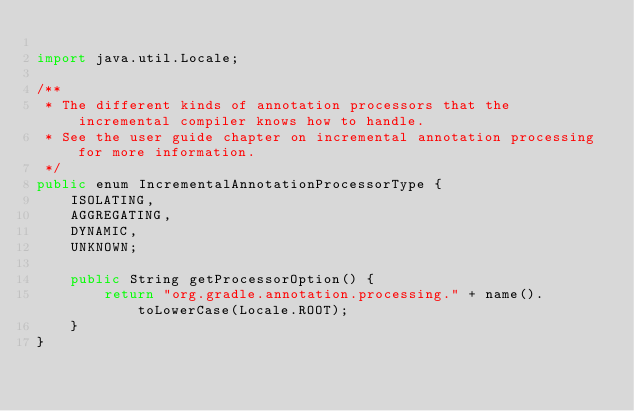Convert code to text. <code><loc_0><loc_0><loc_500><loc_500><_Java_>
import java.util.Locale;

/**
 * The different kinds of annotation processors that the incremental compiler knows how to handle.
 * See the user guide chapter on incremental annotation processing for more information.
 */
public enum IncrementalAnnotationProcessorType {
    ISOLATING,
    AGGREGATING,
    DYNAMIC,
    UNKNOWN;

    public String getProcessorOption() {
        return "org.gradle.annotation.processing." + name().toLowerCase(Locale.ROOT);
    }
}
</code> 